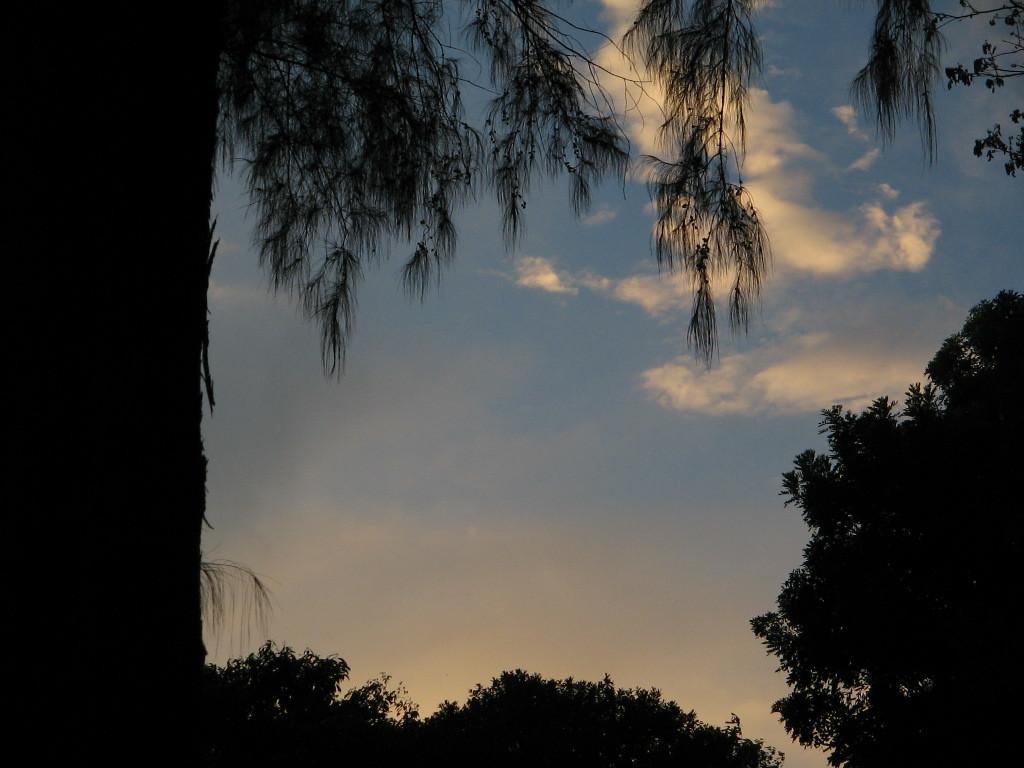Could you give a brief overview of what you see in this image? In this image, we can see some trees and the sky with clouds. 